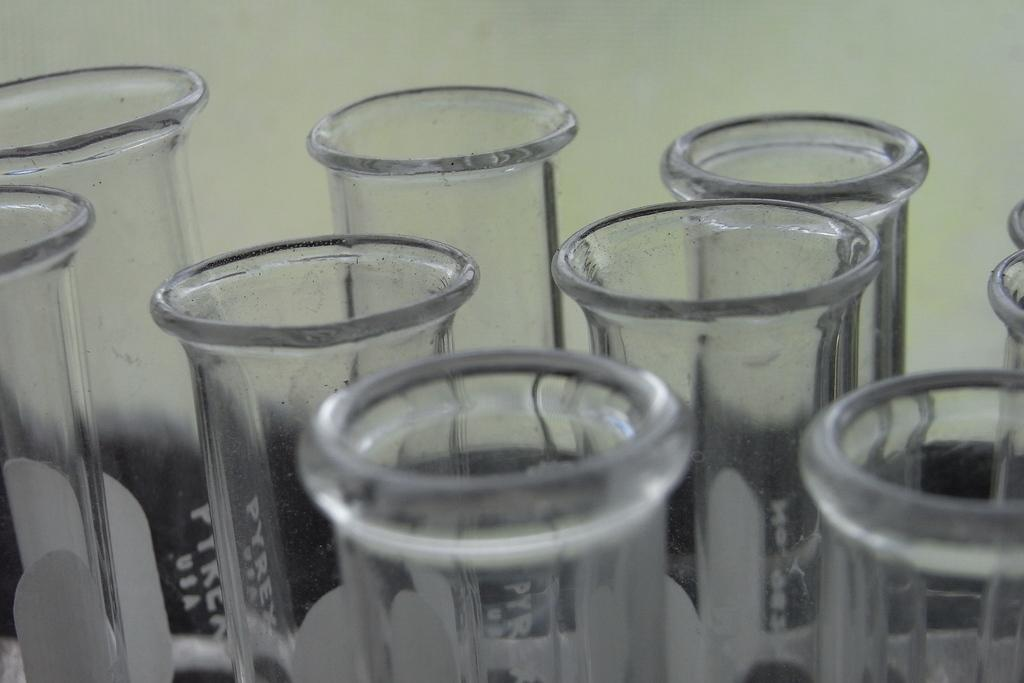What objects can be seen in the image? There are glasses in the image. What can be seen in the background of the image? There is a wall in the background of the image. What type of tent is being offered by the parent in the image? There is no tent or parent present in the image; it only features glasses and a wall in the background. 